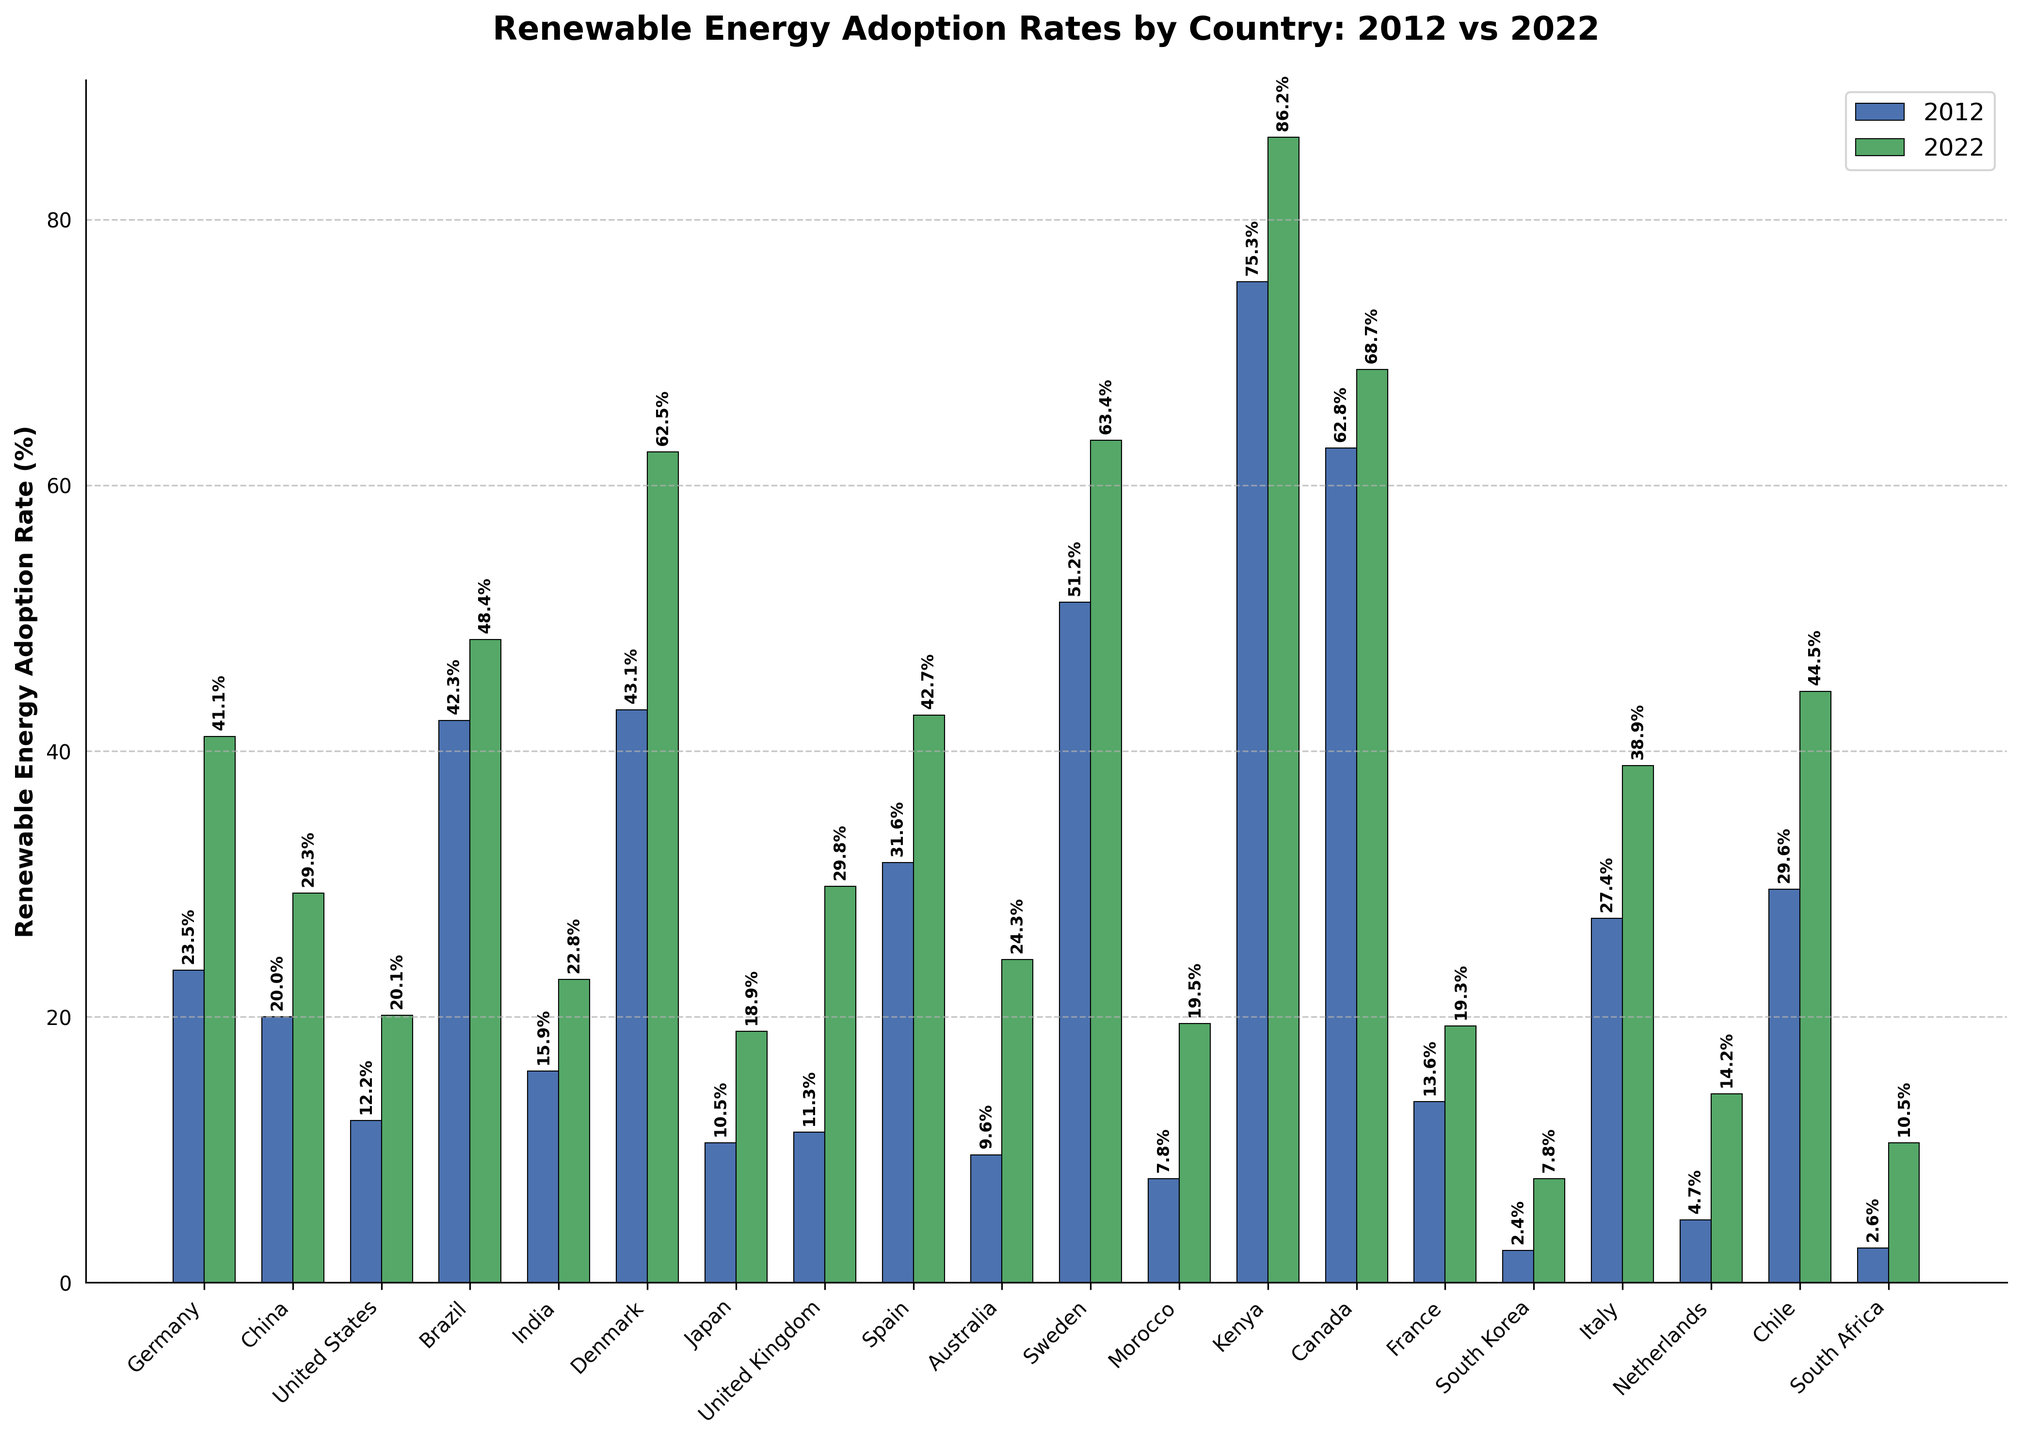What is the average renewable energy adoption rate in 2022 for Germany and Denmark? To find the average, add the renewable energy adoption rates for Germany and Denmark in 2022 together, then divide by 2. (41.1 + 62.5) / 2 = 103.6 / 2 = 51.8
Answer: 51.8 Which country had the highest renewable energy adoption rate in 2022? By looking at the highest bar in the 2022 group of bars, we can see that Kenya's bar is the tallest, indicating it has the highest renewable energy adoption rate in 2022.
Answer: Kenya Did Brazil's renewable energy adoption rate increase or decrease from 2012 to 2022? By comparing the height of the bars for Brazil between 2012 and 2022, we see that the 2022 bar is taller, indicating an increase.
Answer: Increase Which country had the smallest renewable energy adoption rate in 2012? By examining the shortest bar in the 2012 group of bars, we can determine that South Korea had the smallest renewable energy adoption rate in 2012.
Answer: South Korea Is the renewable energy adoption rate higher in Australia or the United Kingdom in 2022? By comparing the height of the bars for Australia and the United Kingdom in 2022, it's evident that the United Kingdom's bar is taller.
Answer: United Kingdom What is the difference in the renewable energy adoption rate between 2012 and 2022 for Italy? Subtract the adoption rate in 2012 for Italy from the adoption rate in 2022 for Italy. 38.9 - 27.4 = 11.5
Answer: 11.5 Which country had the larger increase in renewable energy adoption rate from 2012 to 2022, China or Spain? Calculate the increase for each country: China (29.3 - 20.0 = 9.3) and Spain (42.7 - 31.6 = 11.1). Since 11.1 > 9.3, Spain had the larger increase.
Answer: Spain How many countries had a renewable energy adoption rate greater than 50% in 2022? By looking at the bars for 2022, count the countries whose bars extend above the 50% mark. These countries are Denmark, Sweden, and Kenya, making it a total of 3.
Answer: 3 What is the sum of the renewable energy adoption rates in 2022 for Sweden and Kenya? Add the renewable energy adoption rates for Sweden and Kenya in 2022. 63.4 + 86.2 = 149.6
Answer: 149.6 